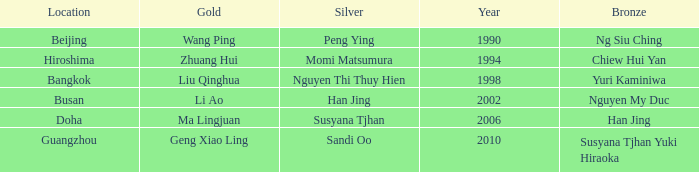What's the lowest Year with the Location of Bangkok? 1998.0. 